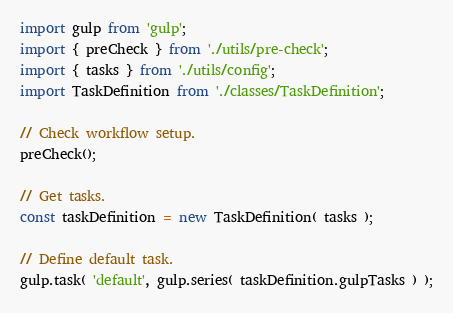Convert code to text. <code><loc_0><loc_0><loc_500><loc_500><_JavaScript_>import gulp from 'gulp';
import { preCheck } from './utils/pre-check';
import { tasks } from './utils/config';
import TaskDefinition from './classes/TaskDefinition';

// Check workflow setup.
preCheck();

// Get tasks.
const taskDefinition = new TaskDefinition( tasks );

// Define default task.
gulp.task( 'default', gulp.series( taskDefinition.gulpTasks ) );
</code> 